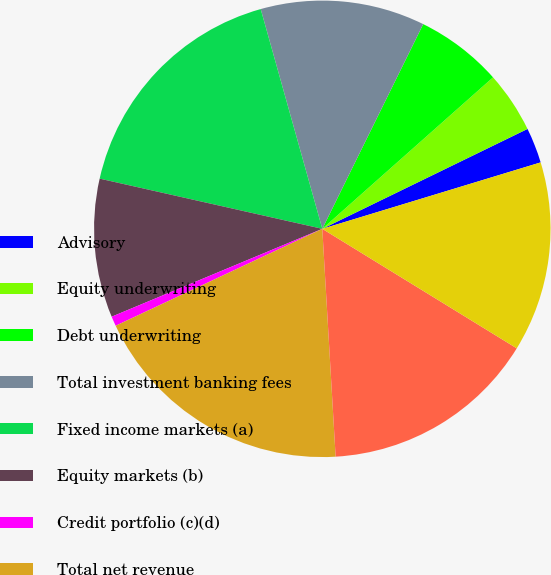Convert chart to OTSL. <chart><loc_0><loc_0><loc_500><loc_500><pie_chart><fcel>Advisory<fcel>Equity underwriting<fcel>Debt underwriting<fcel>Total investment banking fees<fcel>Fixed income markets (a)<fcel>Equity markets (b)<fcel>Credit portfolio (c)(d)<fcel>Total net revenue<fcel>Americas<fcel>Europe/Middle East/Africa<nl><fcel>2.51%<fcel>4.34%<fcel>6.16%<fcel>11.64%<fcel>17.12%<fcel>9.82%<fcel>0.69%<fcel>18.95%<fcel>15.3%<fcel>13.47%<nl></chart> 